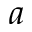<formula> <loc_0><loc_0><loc_500><loc_500>a</formula> 